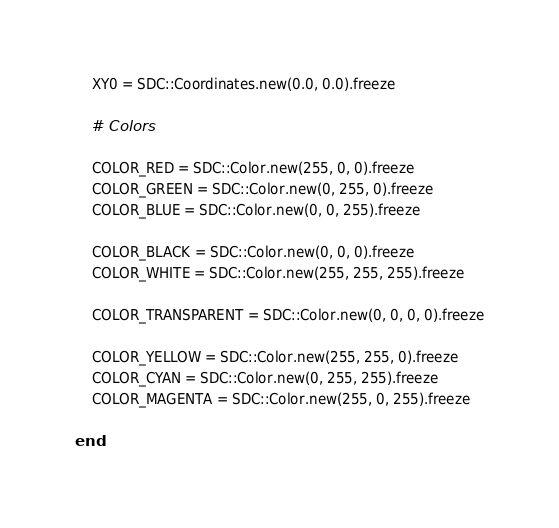Convert code to text. <code><loc_0><loc_0><loc_500><loc_500><_Ruby_>	XY0 = SDC::Coordinates.new(0.0, 0.0).freeze

	# Colors

	COLOR_RED = SDC::Color.new(255, 0, 0).freeze
	COLOR_GREEN = SDC::Color.new(0, 255, 0).freeze
	COLOR_BLUE = SDC::Color.new(0, 0, 255).freeze

	COLOR_BLACK = SDC::Color.new(0, 0, 0).freeze
	COLOR_WHITE = SDC::Color.new(255, 255, 255).freeze

	COLOR_TRANSPARENT = SDC::Color.new(0, 0, 0, 0).freeze

	COLOR_YELLOW = SDC::Color.new(255, 255, 0).freeze
	COLOR_CYAN = SDC::Color.new(0, 255, 255).freeze
	COLOR_MAGENTA = SDC::Color.new(255, 0, 255).freeze

end</code> 